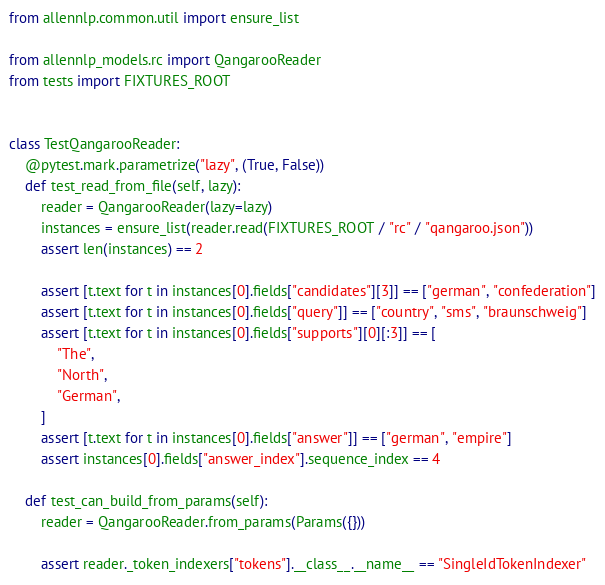<code> <loc_0><loc_0><loc_500><loc_500><_Python_>from allennlp.common.util import ensure_list

from allennlp_models.rc import QangarooReader
from tests import FIXTURES_ROOT


class TestQangarooReader:
    @pytest.mark.parametrize("lazy", (True, False))
    def test_read_from_file(self, lazy):
        reader = QangarooReader(lazy=lazy)
        instances = ensure_list(reader.read(FIXTURES_ROOT / "rc" / "qangaroo.json"))
        assert len(instances) == 2

        assert [t.text for t in instances[0].fields["candidates"][3]] == ["german", "confederation"]
        assert [t.text for t in instances[0].fields["query"]] == ["country", "sms", "braunschweig"]
        assert [t.text for t in instances[0].fields["supports"][0][:3]] == [
            "The",
            "North",
            "German",
        ]
        assert [t.text for t in instances[0].fields["answer"]] == ["german", "empire"]
        assert instances[0].fields["answer_index"].sequence_index == 4

    def test_can_build_from_params(self):
        reader = QangarooReader.from_params(Params({}))

        assert reader._token_indexers["tokens"].__class__.__name__ == "SingleIdTokenIndexer"
</code> 